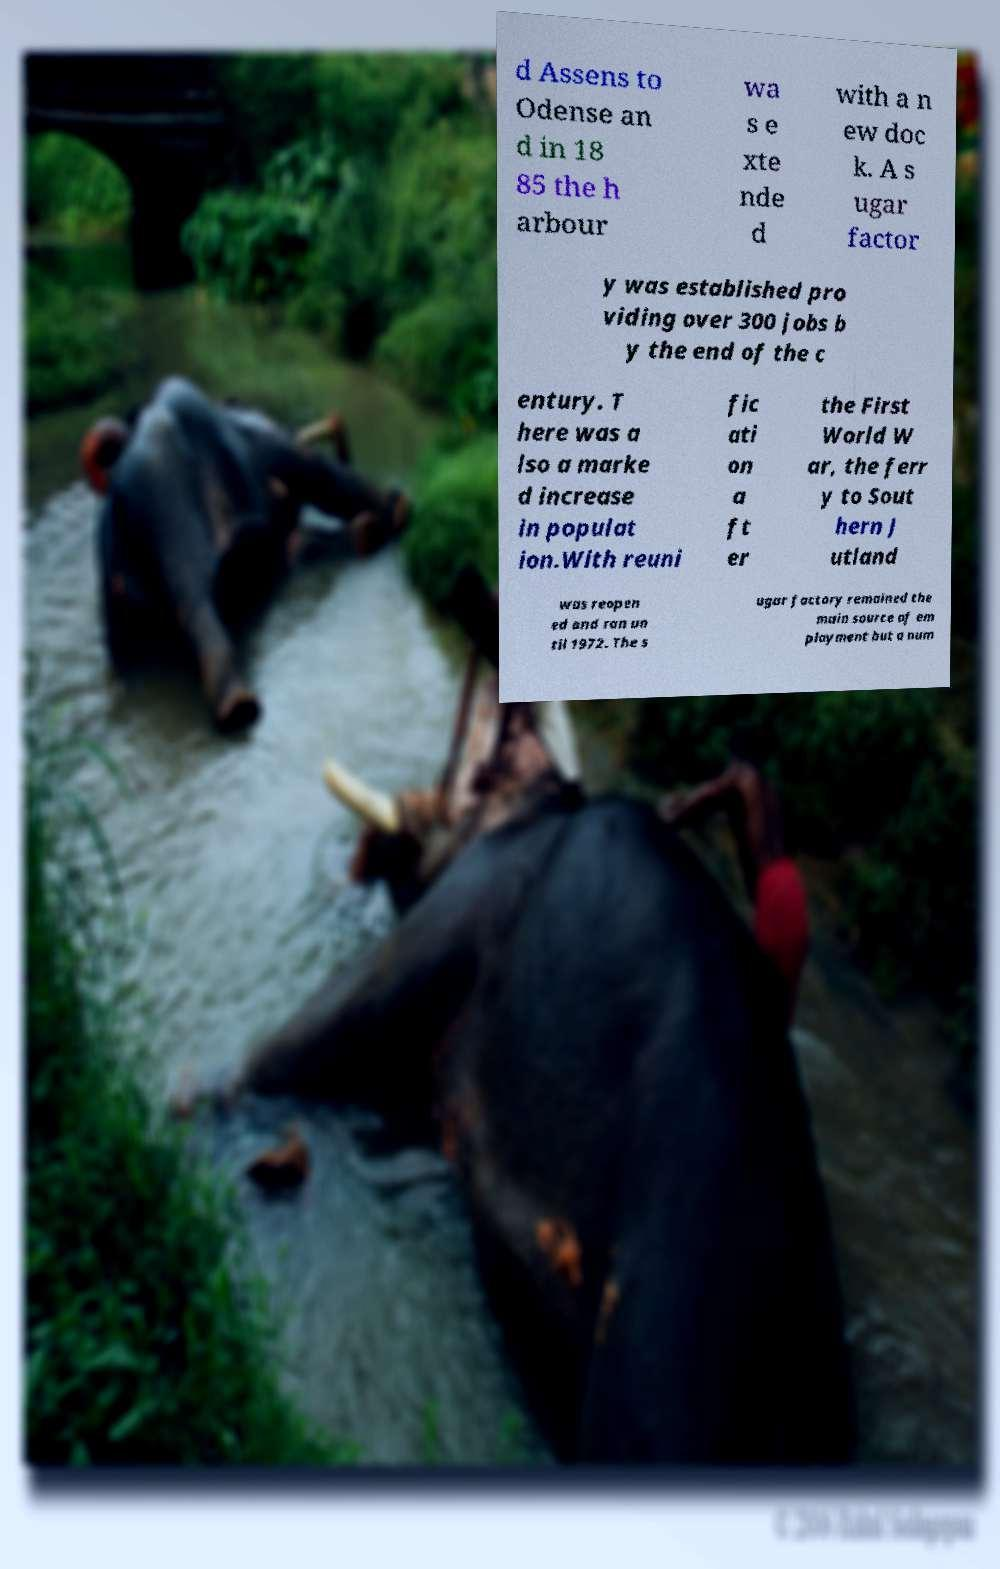I need the written content from this picture converted into text. Can you do that? d Assens to Odense an d in 18 85 the h arbour wa s e xte nde d with a n ew doc k. A s ugar factor y was established pro viding over 300 jobs b y the end of the c entury. T here was a lso a marke d increase in populat ion.With reuni fic ati on a ft er the First World W ar, the ferr y to Sout hern J utland was reopen ed and ran un til 1972. The s ugar factory remained the main source of em ployment but a num 